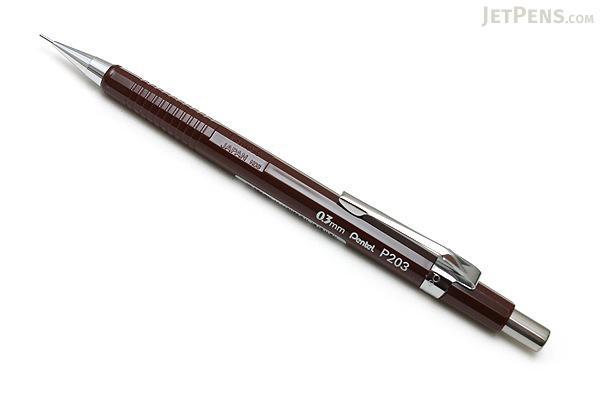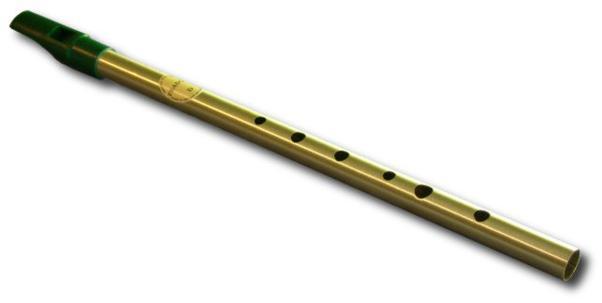The first image is the image on the left, the second image is the image on the right. For the images displayed, is the sentence "One writing implement is visible." factually correct? Answer yes or no. Yes. 